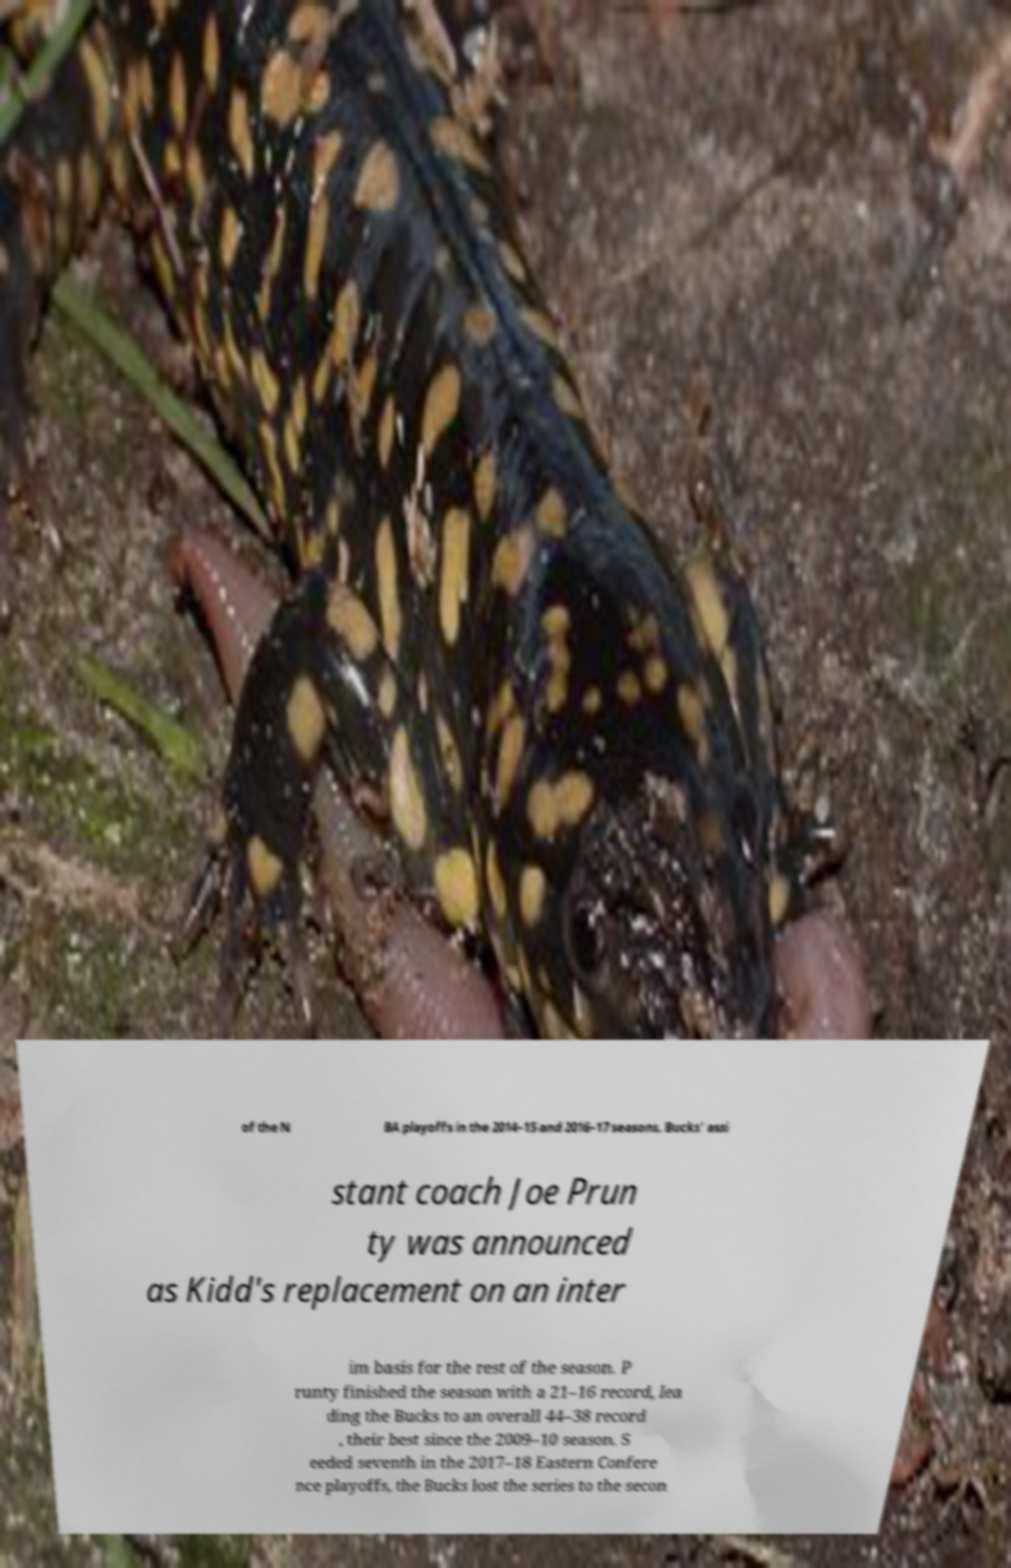Can you read and provide the text displayed in the image?This photo seems to have some interesting text. Can you extract and type it out for me? of the N BA playoffs in the 2014–15 and 2016–17 seasons. Bucks' assi stant coach Joe Prun ty was announced as Kidd's replacement on an inter im basis for the rest of the season. P runty finished the season with a 21–16 record, lea ding the Bucks to an overall 44–38 record , their best since the 2009–10 season. S eeded seventh in the 2017–18 Eastern Confere nce playoffs, the Bucks lost the series to the secon 